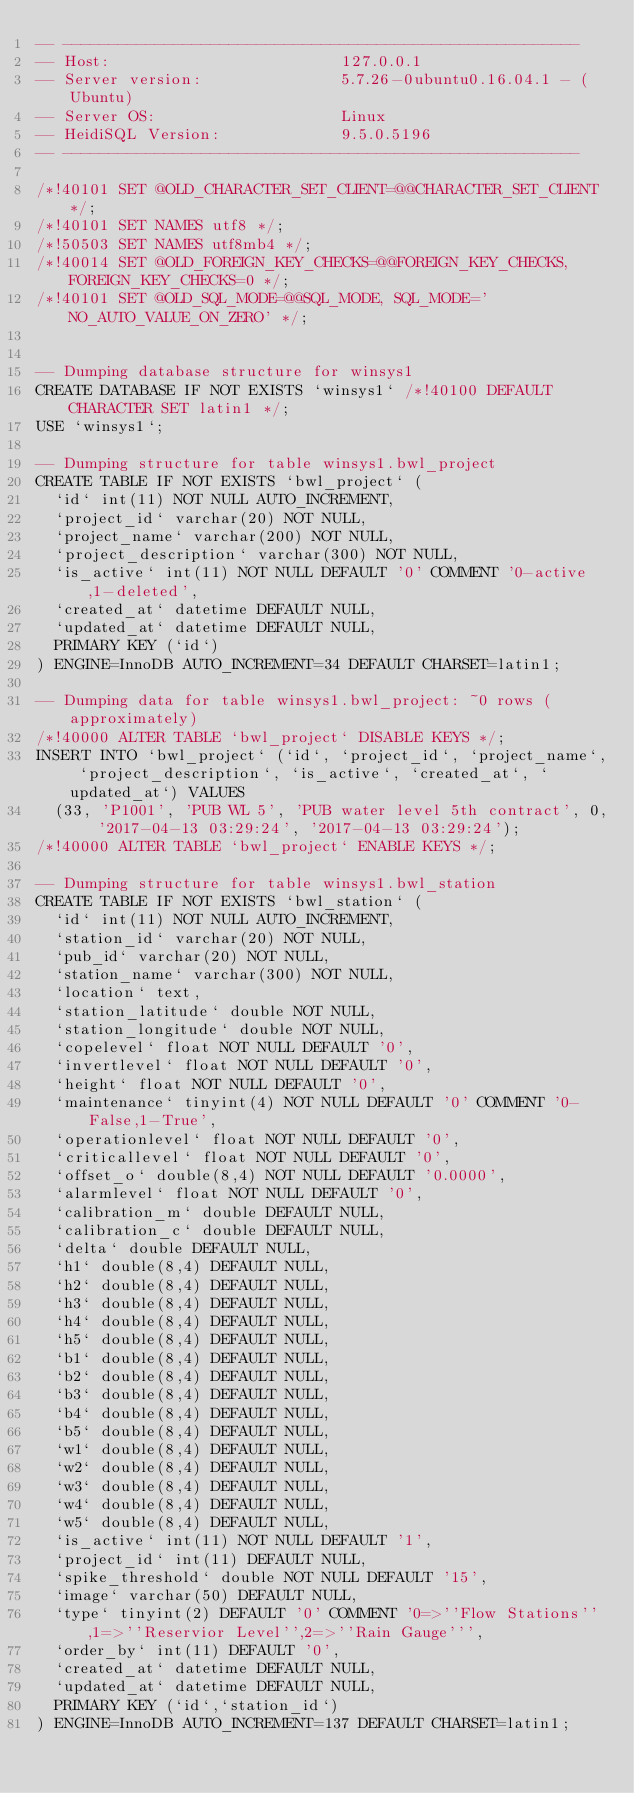<code> <loc_0><loc_0><loc_500><loc_500><_SQL_>-- --------------------------------------------------------
-- Host:                         127.0.0.1
-- Server version:               5.7.26-0ubuntu0.16.04.1 - (Ubuntu)
-- Server OS:                    Linux
-- HeidiSQL Version:             9.5.0.5196
-- --------------------------------------------------------

/*!40101 SET @OLD_CHARACTER_SET_CLIENT=@@CHARACTER_SET_CLIENT */;
/*!40101 SET NAMES utf8 */;
/*!50503 SET NAMES utf8mb4 */;
/*!40014 SET @OLD_FOREIGN_KEY_CHECKS=@@FOREIGN_KEY_CHECKS, FOREIGN_KEY_CHECKS=0 */;
/*!40101 SET @OLD_SQL_MODE=@@SQL_MODE, SQL_MODE='NO_AUTO_VALUE_ON_ZERO' */;


-- Dumping database structure for winsys1
CREATE DATABASE IF NOT EXISTS `winsys1` /*!40100 DEFAULT CHARACTER SET latin1 */;
USE `winsys1`;

-- Dumping structure for table winsys1.bwl_project
CREATE TABLE IF NOT EXISTS `bwl_project` (
  `id` int(11) NOT NULL AUTO_INCREMENT,
  `project_id` varchar(20) NOT NULL,
  `project_name` varchar(200) NOT NULL,
  `project_description` varchar(300) NOT NULL,
  `is_active` int(11) NOT NULL DEFAULT '0' COMMENT '0-active,1-deleted',
  `created_at` datetime DEFAULT NULL,
  `updated_at` datetime DEFAULT NULL,
  PRIMARY KEY (`id`)
) ENGINE=InnoDB AUTO_INCREMENT=34 DEFAULT CHARSET=latin1;

-- Dumping data for table winsys1.bwl_project: ~0 rows (approximately)
/*!40000 ALTER TABLE `bwl_project` DISABLE KEYS */;
INSERT INTO `bwl_project` (`id`, `project_id`, `project_name`, `project_description`, `is_active`, `created_at`, `updated_at`) VALUES
	(33, 'P1001', 'PUB WL 5', 'PUB water level 5th contract', 0, '2017-04-13 03:29:24', '2017-04-13 03:29:24');
/*!40000 ALTER TABLE `bwl_project` ENABLE KEYS */;

-- Dumping structure for table winsys1.bwl_station
CREATE TABLE IF NOT EXISTS `bwl_station` (
  `id` int(11) NOT NULL AUTO_INCREMENT,
  `station_id` varchar(20) NOT NULL,
  `pub_id` varchar(20) NOT NULL,
  `station_name` varchar(300) NOT NULL,
  `location` text,
  `station_latitude` double NOT NULL,
  `station_longitude` double NOT NULL,
  `copelevel` float NOT NULL DEFAULT '0',
  `invertlevel` float NOT NULL DEFAULT '0',
  `height` float NOT NULL DEFAULT '0',
  `maintenance` tinyint(4) NOT NULL DEFAULT '0' COMMENT '0-False,1-True',
  `operationlevel` float NOT NULL DEFAULT '0',
  `criticallevel` float NOT NULL DEFAULT '0',
  `offset_o` double(8,4) NOT NULL DEFAULT '0.0000',
  `alarmlevel` float NOT NULL DEFAULT '0',
  `calibration_m` double DEFAULT NULL,
  `calibration_c` double DEFAULT NULL,
  `delta` double DEFAULT NULL,
  `h1` double(8,4) DEFAULT NULL,
  `h2` double(8,4) DEFAULT NULL,
  `h3` double(8,4) DEFAULT NULL,
  `h4` double(8,4) DEFAULT NULL,
  `h5` double(8,4) DEFAULT NULL,
  `b1` double(8,4) DEFAULT NULL,
  `b2` double(8,4) DEFAULT NULL,
  `b3` double(8,4) DEFAULT NULL,
  `b4` double(8,4) DEFAULT NULL,
  `b5` double(8,4) DEFAULT NULL,
  `w1` double(8,4) DEFAULT NULL,
  `w2` double(8,4) DEFAULT NULL,
  `w3` double(8,4) DEFAULT NULL,
  `w4` double(8,4) DEFAULT NULL,
  `w5` double(8,4) DEFAULT NULL,
  `is_active` int(11) NOT NULL DEFAULT '1',
  `project_id` int(11) DEFAULT NULL,
  `spike_threshold` double NOT NULL DEFAULT '15',
  `image` varchar(50) DEFAULT NULL,
  `type` tinyint(2) DEFAULT '0' COMMENT '0=>''Flow Stations'',1=>''Reservior Level'',2=>''Rain Gauge''',
  `order_by` int(11) DEFAULT '0',
  `created_at` datetime DEFAULT NULL,
  `updated_at` datetime DEFAULT NULL,
  PRIMARY KEY (`id`,`station_id`)
) ENGINE=InnoDB AUTO_INCREMENT=137 DEFAULT CHARSET=latin1;
</code> 